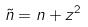<formula> <loc_0><loc_0><loc_500><loc_500>\tilde { n } = n + z ^ { 2 }</formula> 